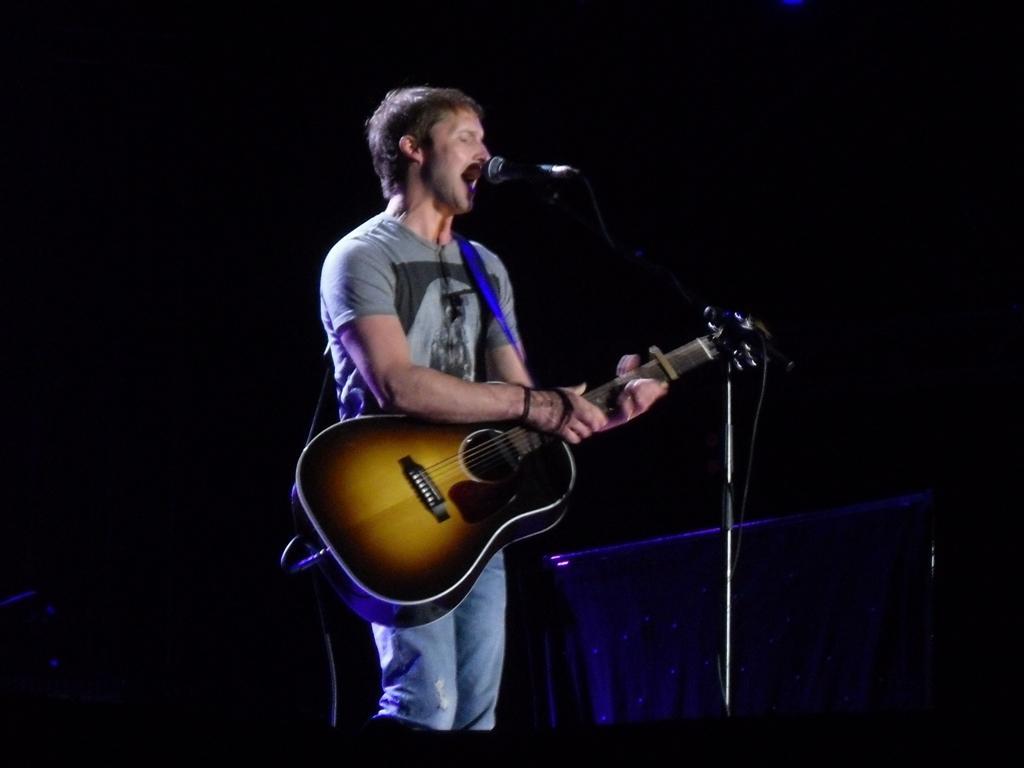In one or two sentences, can you explain what this image depicts? This man is playing guitar and singing in-front of mic. Background is in black color. 